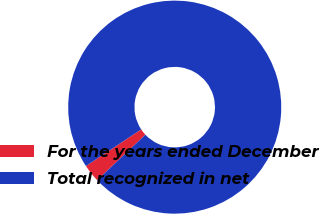<chart> <loc_0><loc_0><loc_500><loc_500><pie_chart><fcel>For the years ended December<fcel>Total recognized in net<nl><fcel>2.7%<fcel>97.3%<nl></chart> 